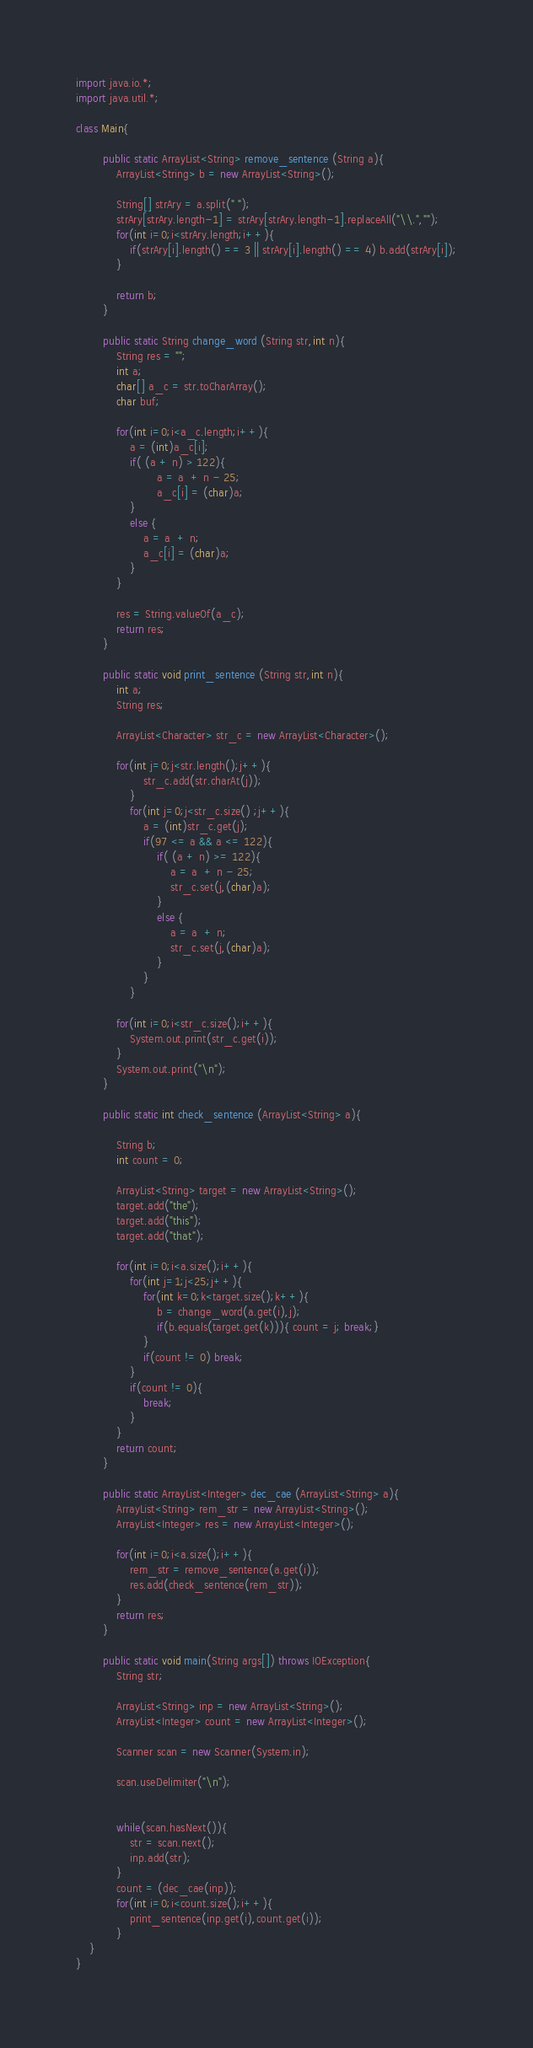Convert code to text. <code><loc_0><loc_0><loc_500><loc_500><_Java_>import java.io.*;
import java.util.*;

class Main{
	
		public static ArrayList<String> remove_sentence (String a){
			ArrayList<String> b = new ArrayList<String>();
			
			String[] strAry = a.split(" ");
			strAry[strAry.length-1] = strAry[strAry.length-1].replaceAll("\\.","");
			for(int i=0;i<strAry.length;i++){
				if(strAry[i].length() == 3 || strAry[i].length() == 4) b.add(strAry[i]);
			}
			
			return b;
		}
		
		public static String change_word (String str,int n){
			String res = "";
			int a;
			char[] a_c = str.toCharArray();
			char buf;
			
			for(int i=0;i<a_c.length;i++){
				a = (int)a_c[i];
				if( (a + n) > 122){
						a = a  + n - 25;
						a_c[i] = (char)a;
				}
				else {
					a = a  + n;
					a_c[i] = (char)a;
				}
			}
			
			res = String.valueOf(a_c);
			return res;
		}
		
		public static void print_sentence (String str,int n){
			int a;
			String res;
			
			ArrayList<Character> str_c = new ArrayList<Character>();
			
			for(int j=0;j<str.length();j++){
					str_c.add(str.charAt(j));
				}
				for(int j=0;j<str_c.size() ;j++){
					a = (int)str_c.get(j);
					if(97 <= a && a <= 122){
						if( (a + n) >= 122){
							a = a  + n - 25;
							str_c.set(j,(char)a);
						}
						else {
							a = a  + n;
							str_c.set(j,(char)a);
						}
					}
				}
				
			for(int i=0;i<str_c.size();i++){
				System.out.print(str_c.get(i));
			}
			System.out.print("\n");
		}
		
		public static int check_sentence (ArrayList<String> a){
			
			String b;
			int count = 0;

			ArrayList<String> target = new ArrayList<String>();
			target.add("the");
			target.add("this");
			target.add("that");
			
			for(int i=0;i<a.size();i++){
				for(int j=1;j<25;j++){
					for(int k=0;k<target.size();k++){
						b = change_word(a.get(i),j);
						if(b.equals(target.get(k))){ count = j; break;}
					}
					if(count != 0) break;
				}
				if(count != 0){
					break;
				}
			}
			return count;
		}
		
		public static ArrayList<Integer> dec_cae (ArrayList<String> a){
			ArrayList<String> rem_str = new ArrayList<String>();
			ArrayList<Integer> res = new ArrayList<Integer>();	
			
			for(int i=0;i<a.size();i++){
				rem_str = remove_sentence(a.get(i));
				res.add(check_sentence(rem_str));
			}
			return res;
		}
		
		public static void main(String args[]) throws IOException{
			String str;

			ArrayList<String> inp = new ArrayList<String>();
			ArrayList<Integer> count = new ArrayList<Integer>();

			Scanner scan = new Scanner(System.in);

			scan.useDelimiter("\n");

			
			while(scan.hasNext()){
				str = scan.next();
				inp.add(str);
			}
			count = (dec_cae(inp));
			for(int i=0;i<count.size();i++){
				print_sentence(inp.get(i),count.get(i));
			}
	}
}</code> 